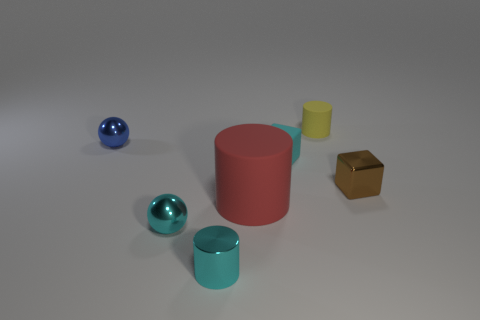Add 2 yellow rubber objects. How many objects exist? 9 Subtract all balls. How many objects are left? 5 Subtract all yellow rubber objects. Subtract all small metal spheres. How many objects are left? 4 Add 4 small metal things. How many small metal things are left? 8 Add 6 big rubber spheres. How many big rubber spheres exist? 6 Subtract 0 brown balls. How many objects are left? 7 